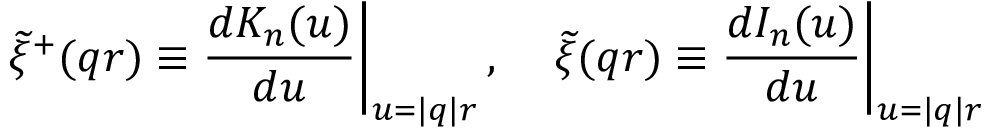<formula> <loc_0><loc_0><loc_500><loc_500>\widetilde { \xi } ^ { + } ( q r ) \equiv \frac { d K _ { n } ( u ) } { d u } \right | _ { u = | q | r } , \quad \widetilde { \xi } ( q r ) \equiv \frac { d I _ { n } ( u ) } { d u } \right | _ { u = | q | r }</formula> 